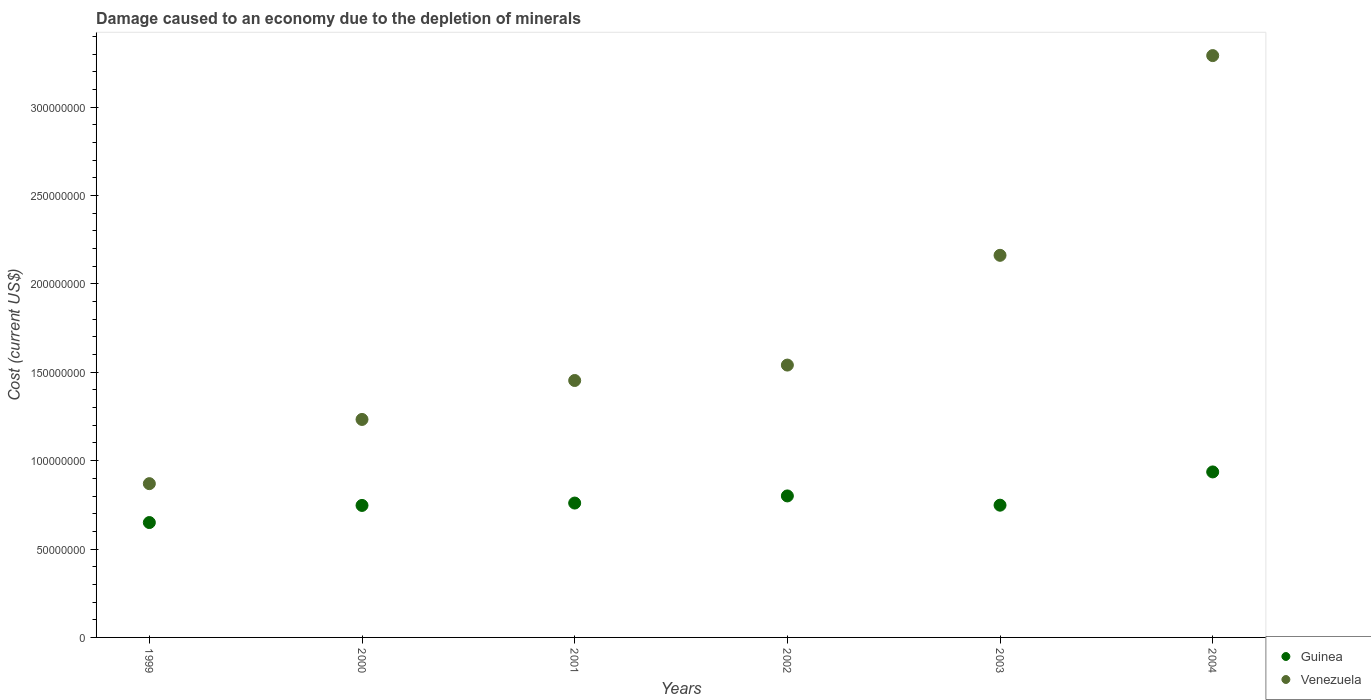How many different coloured dotlines are there?
Offer a terse response. 2. What is the cost of damage caused due to the depletion of minerals in Venezuela in 2004?
Ensure brevity in your answer.  3.29e+08. Across all years, what is the maximum cost of damage caused due to the depletion of minerals in Guinea?
Your response must be concise. 9.36e+07. Across all years, what is the minimum cost of damage caused due to the depletion of minerals in Venezuela?
Give a very brief answer. 8.70e+07. In which year was the cost of damage caused due to the depletion of minerals in Venezuela minimum?
Your answer should be compact. 1999. What is the total cost of damage caused due to the depletion of minerals in Venezuela in the graph?
Keep it short and to the point. 1.06e+09. What is the difference between the cost of damage caused due to the depletion of minerals in Venezuela in 2002 and that in 2004?
Ensure brevity in your answer.  -1.75e+08. What is the difference between the cost of damage caused due to the depletion of minerals in Guinea in 2002 and the cost of damage caused due to the depletion of minerals in Venezuela in 1999?
Make the answer very short. -6.94e+06. What is the average cost of damage caused due to the depletion of minerals in Guinea per year?
Give a very brief answer. 7.74e+07. In the year 2000, what is the difference between the cost of damage caused due to the depletion of minerals in Venezuela and cost of damage caused due to the depletion of minerals in Guinea?
Provide a succinct answer. 4.86e+07. What is the ratio of the cost of damage caused due to the depletion of minerals in Guinea in 2001 to that in 2003?
Give a very brief answer. 1.02. What is the difference between the highest and the second highest cost of damage caused due to the depletion of minerals in Guinea?
Provide a succinct answer. 1.36e+07. What is the difference between the highest and the lowest cost of damage caused due to the depletion of minerals in Guinea?
Your answer should be compact. 2.86e+07. In how many years, is the cost of damage caused due to the depletion of minerals in Guinea greater than the average cost of damage caused due to the depletion of minerals in Guinea taken over all years?
Your answer should be compact. 2. Is the sum of the cost of damage caused due to the depletion of minerals in Venezuela in 1999 and 2002 greater than the maximum cost of damage caused due to the depletion of minerals in Guinea across all years?
Your answer should be compact. Yes. Does the cost of damage caused due to the depletion of minerals in Guinea monotonically increase over the years?
Your response must be concise. No. Is the cost of damage caused due to the depletion of minerals in Venezuela strictly greater than the cost of damage caused due to the depletion of minerals in Guinea over the years?
Keep it short and to the point. Yes. Is the cost of damage caused due to the depletion of minerals in Guinea strictly less than the cost of damage caused due to the depletion of minerals in Venezuela over the years?
Provide a short and direct response. Yes. What is the difference between two consecutive major ticks on the Y-axis?
Provide a short and direct response. 5.00e+07. Does the graph contain any zero values?
Your answer should be very brief. No. Does the graph contain grids?
Keep it short and to the point. No. What is the title of the graph?
Offer a very short reply. Damage caused to an economy due to the depletion of minerals. Does "Syrian Arab Republic" appear as one of the legend labels in the graph?
Your answer should be compact. No. What is the label or title of the X-axis?
Offer a very short reply. Years. What is the label or title of the Y-axis?
Make the answer very short. Cost (current US$). What is the Cost (current US$) in Guinea in 1999?
Make the answer very short. 6.50e+07. What is the Cost (current US$) of Venezuela in 1999?
Keep it short and to the point. 8.70e+07. What is the Cost (current US$) in Guinea in 2000?
Give a very brief answer. 7.47e+07. What is the Cost (current US$) of Venezuela in 2000?
Make the answer very short. 1.23e+08. What is the Cost (current US$) in Guinea in 2001?
Offer a terse response. 7.60e+07. What is the Cost (current US$) in Venezuela in 2001?
Your answer should be very brief. 1.45e+08. What is the Cost (current US$) in Guinea in 2002?
Offer a very short reply. 8.00e+07. What is the Cost (current US$) of Venezuela in 2002?
Provide a succinct answer. 1.54e+08. What is the Cost (current US$) of Guinea in 2003?
Make the answer very short. 7.48e+07. What is the Cost (current US$) of Venezuela in 2003?
Provide a short and direct response. 2.16e+08. What is the Cost (current US$) in Guinea in 2004?
Your answer should be compact. 9.36e+07. What is the Cost (current US$) in Venezuela in 2004?
Provide a short and direct response. 3.29e+08. Across all years, what is the maximum Cost (current US$) of Guinea?
Ensure brevity in your answer.  9.36e+07. Across all years, what is the maximum Cost (current US$) of Venezuela?
Your answer should be very brief. 3.29e+08. Across all years, what is the minimum Cost (current US$) of Guinea?
Offer a terse response. 6.50e+07. Across all years, what is the minimum Cost (current US$) in Venezuela?
Provide a short and direct response. 8.70e+07. What is the total Cost (current US$) of Guinea in the graph?
Keep it short and to the point. 4.64e+08. What is the total Cost (current US$) of Venezuela in the graph?
Give a very brief answer. 1.06e+09. What is the difference between the Cost (current US$) in Guinea in 1999 and that in 2000?
Offer a very short reply. -9.68e+06. What is the difference between the Cost (current US$) in Venezuela in 1999 and that in 2000?
Your answer should be compact. -3.63e+07. What is the difference between the Cost (current US$) of Guinea in 1999 and that in 2001?
Provide a short and direct response. -1.10e+07. What is the difference between the Cost (current US$) of Venezuela in 1999 and that in 2001?
Your response must be concise. -5.84e+07. What is the difference between the Cost (current US$) in Guinea in 1999 and that in 2002?
Offer a very short reply. -1.51e+07. What is the difference between the Cost (current US$) of Venezuela in 1999 and that in 2002?
Your answer should be very brief. -6.71e+07. What is the difference between the Cost (current US$) of Guinea in 1999 and that in 2003?
Offer a very short reply. -9.82e+06. What is the difference between the Cost (current US$) of Venezuela in 1999 and that in 2003?
Offer a terse response. -1.29e+08. What is the difference between the Cost (current US$) of Guinea in 1999 and that in 2004?
Provide a succinct answer. -2.86e+07. What is the difference between the Cost (current US$) of Venezuela in 1999 and that in 2004?
Your response must be concise. -2.42e+08. What is the difference between the Cost (current US$) in Guinea in 2000 and that in 2001?
Keep it short and to the point. -1.34e+06. What is the difference between the Cost (current US$) in Venezuela in 2000 and that in 2001?
Your answer should be very brief. -2.20e+07. What is the difference between the Cost (current US$) in Guinea in 2000 and that in 2002?
Give a very brief answer. -5.37e+06. What is the difference between the Cost (current US$) in Venezuela in 2000 and that in 2002?
Offer a very short reply. -3.08e+07. What is the difference between the Cost (current US$) in Guinea in 2000 and that in 2003?
Your answer should be compact. -1.39e+05. What is the difference between the Cost (current US$) in Venezuela in 2000 and that in 2003?
Keep it short and to the point. -9.28e+07. What is the difference between the Cost (current US$) in Guinea in 2000 and that in 2004?
Offer a terse response. -1.89e+07. What is the difference between the Cost (current US$) of Venezuela in 2000 and that in 2004?
Give a very brief answer. -2.06e+08. What is the difference between the Cost (current US$) of Guinea in 2001 and that in 2002?
Offer a terse response. -4.04e+06. What is the difference between the Cost (current US$) of Venezuela in 2001 and that in 2002?
Provide a short and direct response. -8.72e+06. What is the difference between the Cost (current US$) in Guinea in 2001 and that in 2003?
Your answer should be compact. 1.20e+06. What is the difference between the Cost (current US$) in Venezuela in 2001 and that in 2003?
Offer a very short reply. -7.08e+07. What is the difference between the Cost (current US$) in Guinea in 2001 and that in 2004?
Keep it short and to the point. -1.76e+07. What is the difference between the Cost (current US$) of Venezuela in 2001 and that in 2004?
Offer a terse response. -1.84e+08. What is the difference between the Cost (current US$) in Guinea in 2002 and that in 2003?
Your answer should be compact. 5.24e+06. What is the difference between the Cost (current US$) of Venezuela in 2002 and that in 2003?
Offer a terse response. -6.21e+07. What is the difference between the Cost (current US$) in Guinea in 2002 and that in 2004?
Offer a terse response. -1.36e+07. What is the difference between the Cost (current US$) of Venezuela in 2002 and that in 2004?
Offer a terse response. -1.75e+08. What is the difference between the Cost (current US$) in Guinea in 2003 and that in 2004?
Keep it short and to the point. -1.88e+07. What is the difference between the Cost (current US$) in Venezuela in 2003 and that in 2004?
Keep it short and to the point. -1.13e+08. What is the difference between the Cost (current US$) in Guinea in 1999 and the Cost (current US$) in Venezuela in 2000?
Make the answer very short. -5.83e+07. What is the difference between the Cost (current US$) of Guinea in 1999 and the Cost (current US$) of Venezuela in 2001?
Give a very brief answer. -8.04e+07. What is the difference between the Cost (current US$) in Guinea in 1999 and the Cost (current US$) in Venezuela in 2002?
Ensure brevity in your answer.  -8.91e+07. What is the difference between the Cost (current US$) of Guinea in 1999 and the Cost (current US$) of Venezuela in 2003?
Make the answer very short. -1.51e+08. What is the difference between the Cost (current US$) in Guinea in 1999 and the Cost (current US$) in Venezuela in 2004?
Give a very brief answer. -2.64e+08. What is the difference between the Cost (current US$) of Guinea in 2000 and the Cost (current US$) of Venezuela in 2001?
Offer a terse response. -7.07e+07. What is the difference between the Cost (current US$) in Guinea in 2000 and the Cost (current US$) in Venezuela in 2002?
Give a very brief answer. -7.94e+07. What is the difference between the Cost (current US$) of Guinea in 2000 and the Cost (current US$) of Venezuela in 2003?
Your answer should be compact. -1.41e+08. What is the difference between the Cost (current US$) in Guinea in 2000 and the Cost (current US$) in Venezuela in 2004?
Provide a succinct answer. -2.54e+08. What is the difference between the Cost (current US$) in Guinea in 2001 and the Cost (current US$) in Venezuela in 2002?
Provide a succinct answer. -7.81e+07. What is the difference between the Cost (current US$) in Guinea in 2001 and the Cost (current US$) in Venezuela in 2003?
Give a very brief answer. -1.40e+08. What is the difference between the Cost (current US$) of Guinea in 2001 and the Cost (current US$) of Venezuela in 2004?
Offer a terse response. -2.53e+08. What is the difference between the Cost (current US$) in Guinea in 2002 and the Cost (current US$) in Venezuela in 2003?
Your answer should be compact. -1.36e+08. What is the difference between the Cost (current US$) of Guinea in 2002 and the Cost (current US$) of Venezuela in 2004?
Your answer should be compact. -2.49e+08. What is the difference between the Cost (current US$) of Guinea in 2003 and the Cost (current US$) of Venezuela in 2004?
Ensure brevity in your answer.  -2.54e+08. What is the average Cost (current US$) in Guinea per year?
Offer a terse response. 7.74e+07. What is the average Cost (current US$) of Venezuela per year?
Offer a very short reply. 1.76e+08. In the year 1999, what is the difference between the Cost (current US$) in Guinea and Cost (current US$) in Venezuela?
Your answer should be very brief. -2.20e+07. In the year 2000, what is the difference between the Cost (current US$) of Guinea and Cost (current US$) of Venezuela?
Make the answer very short. -4.86e+07. In the year 2001, what is the difference between the Cost (current US$) of Guinea and Cost (current US$) of Venezuela?
Make the answer very short. -6.93e+07. In the year 2002, what is the difference between the Cost (current US$) of Guinea and Cost (current US$) of Venezuela?
Provide a succinct answer. -7.40e+07. In the year 2003, what is the difference between the Cost (current US$) of Guinea and Cost (current US$) of Venezuela?
Ensure brevity in your answer.  -1.41e+08. In the year 2004, what is the difference between the Cost (current US$) of Guinea and Cost (current US$) of Venezuela?
Offer a very short reply. -2.36e+08. What is the ratio of the Cost (current US$) of Guinea in 1999 to that in 2000?
Your answer should be very brief. 0.87. What is the ratio of the Cost (current US$) of Venezuela in 1999 to that in 2000?
Give a very brief answer. 0.71. What is the ratio of the Cost (current US$) of Guinea in 1999 to that in 2001?
Offer a very short reply. 0.85. What is the ratio of the Cost (current US$) of Venezuela in 1999 to that in 2001?
Provide a succinct answer. 0.6. What is the ratio of the Cost (current US$) in Guinea in 1999 to that in 2002?
Ensure brevity in your answer.  0.81. What is the ratio of the Cost (current US$) in Venezuela in 1999 to that in 2002?
Offer a terse response. 0.56. What is the ratio of the Cost (current US$) of Guinea in 1999 to that in 2003?
Your response must be concise. 0.87. What is the ratio of the Cost (current US$) in Venezuela in 1999 to that in 2003?
Offer a very short reply. 0.4. What is the ratio of the Cost (current US$) of Guinea in 1999 to that in 2004?
Provide a short and direct response. 0.69. What is the ratio of the Cost (current US$) of Venezuela in 1999 to that in 2004?
Your answer should be compact. 0.26. What is the ratio of the Cost (current US$) in Guinea in 2000 to that in 2001?
Your answer should be very brief. 0.98. What is the ratio of the Cost (current US$) of Venezuela in 2000 to that in 2001?
Keep it short and to the point. 0.85. What is the ratio of the Cost (current US$) in Guinea in 2000 to that in 2002?
Provide a succinct answer. 0.93. What is the ratio of the Cost (current US$) in Venezuela in 2000 to that in 2002?
Keep it short and to the point. 0.8. What is the ratio of the Cost (current US$) in Venezuela in 2000 to that in 2003?
Make the answer very short. 0.57. What is the ratio of the Cost (current US$) in Guinea in 2000 to that in 2004?
Offer a very short reply. 0.8. What is the ratio of the Cost (current US$) of Venezuela in 2000 to that in 2004?
Offer a very short reply. 0.37. What is the ratio of the Cost (current US$) of Guinea in 2001 to that in 2002?
Keep it short and to the point. 0.95. What is the ratio of the Cost (current US$) in Venezuela in 2001 to that in 2002?
Provide a succinct answer. 0.94. What is the ratio of the Cost (current US$) in Venezuela in 2001 to that in 2003?
Your answer should be very brief. 0.67. What is the ratio of the Cost (current US$) of Guinea in 2001 to that in 2004?
Make the answer very short. 0.81. What is the ratio of the Cost (current US$) in Venezuela in 2001 to that in 2004?
Your answer should be compact. 0.44. What is the ratio of the Cost (current US$) in Guinea in 2002 to that in 2003?
Provide a succinct answer. 1.07. What is the ratio of the Cost (current US$) in Venezuela in 2002 to that in 2003?
Keep it short and to the point. 0.71. What is the ratio of the Cost (current US$) of Guinea in 2002 to that in 2004?
Ensure brevity in your answer.  0.85. What is the ratio of the Cost (current US$) in Venezuela in 2002 to that in 2004?
Offer a very short reply. 0.47. What is the ratio of the Cost (current US$) of Guinea in 2003 to that in 2004?
Offer a terse response. 0.8. What is the ratio of the Cost (current US$) of Venezuela in 2003 to that in 2004?
Offer a terse response. 0.66. What is the difference between the highest and the second highest Cost (current US$) of Guinea?
Offer a terse response. 1.36e+07. What is the difference between the highest and the second highest Cost (current US$) of Venezuela?
Your answer should be very brief. 1.13e+08. What is the difference between the highest and the lowest Cost (current US$) of Guinea?
Offer a terse response. 2.86e+07. What is the difference between the highest and the lowest Cost (current US$) in Venezuela?
Your answer should be compact. 2.42e+08. 